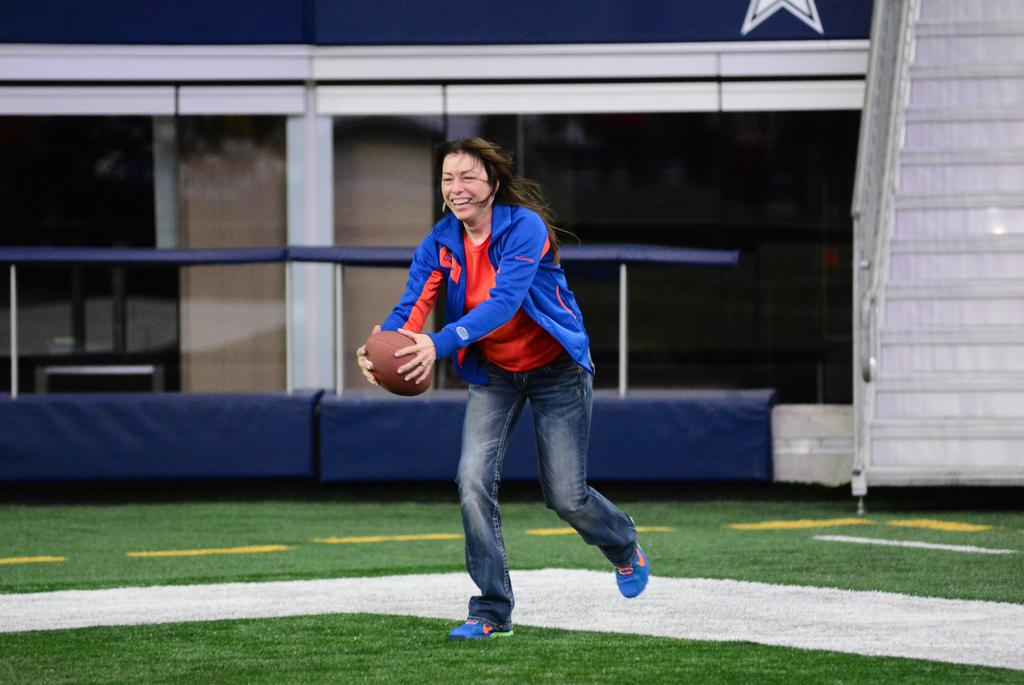Who is present in the image? There is a woman in the image. What is the woman holding in the image? The woman is holding a rugby ball. What is the woman's posture in the image? The woman is standing in the image. What type of surface is visible in the image? There is grass in the image. What architectural feature can be seen in the image? There are stairs in the image. What type of building is visible in the background of the image? There is a building with glass doors in the background of the image. How many cars can be seen parked on the grass in the image? There are no cars visible in the image; it features a woman holding a rugby ball, grass, stairs, and a building with glass doors in the background. 